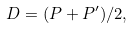Convert formula to latex. <formula><loc_0><loc_0><loc_500><loc_500>D = ( P + P ^ { \prime } ) / 2 ,</formula> 